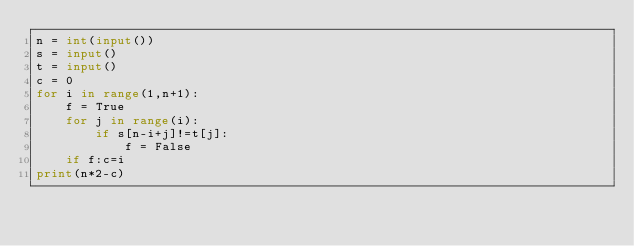Convert code to text. <code><loc_0><loc_0><loc_500><loc_500><_Python_>n = int(input())
s = input()
t = input()
c = 0
for i in range(1,n+1):
    f = True
    for j in range(i):
        if s[n-i+j]!=t[j]:
            f = False
    if f:c=i
print(n*2-c)
</code> 